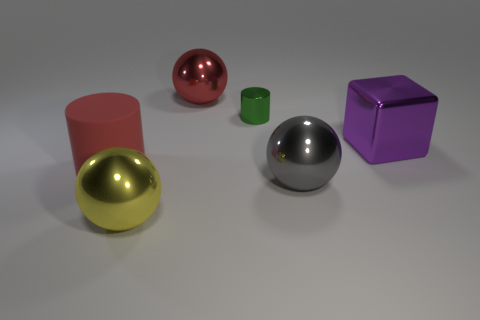Subtract all large gray spheres. How many spheres are left? 2 Add 1 purple shiny objects. How many objects exist? 7 Subtract all cylinders. How many objects are left? 4 Subtract 1 purple blocks. How many objects are left? 5 Subtract all small purple things. Subtract all green things. How many objects are left? 5 Add 1 large red things. How many large red things are left? 3 Add 3 big cylinders. How many big cylinders exist? 4 